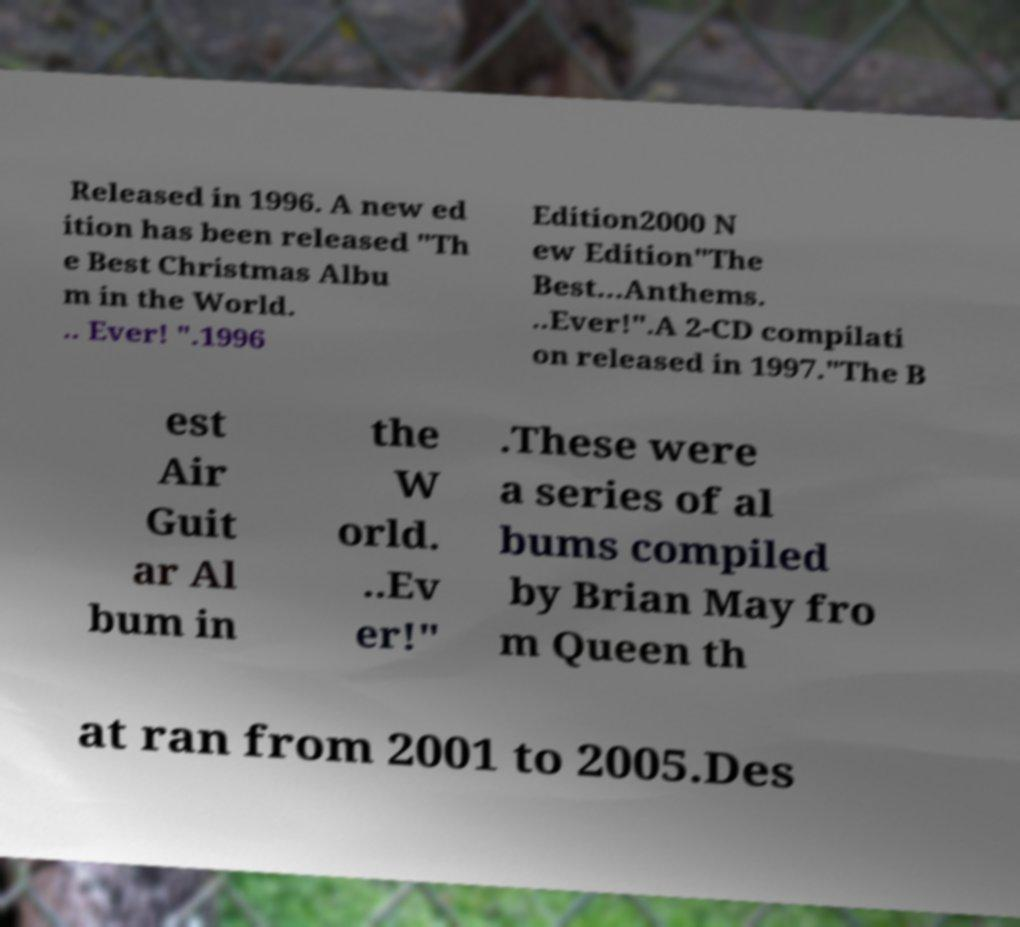I need the written content from this picture converted into text. Can you do that? Released in 1996. A new ed ition has been released "Th e Best Christmas Albu m in the World. .. Ever! ".1996 Edition2000 N ew Edition"The Best...Anthems. ..Ever!".A 2-CD compilati on released in 1997."The B est Air Guit ar Al bum in the W orld. ..Ev er!" .These were a series of al bums compiled by Brian May fro m Queen th at ran from 2001 to 2005.Des 